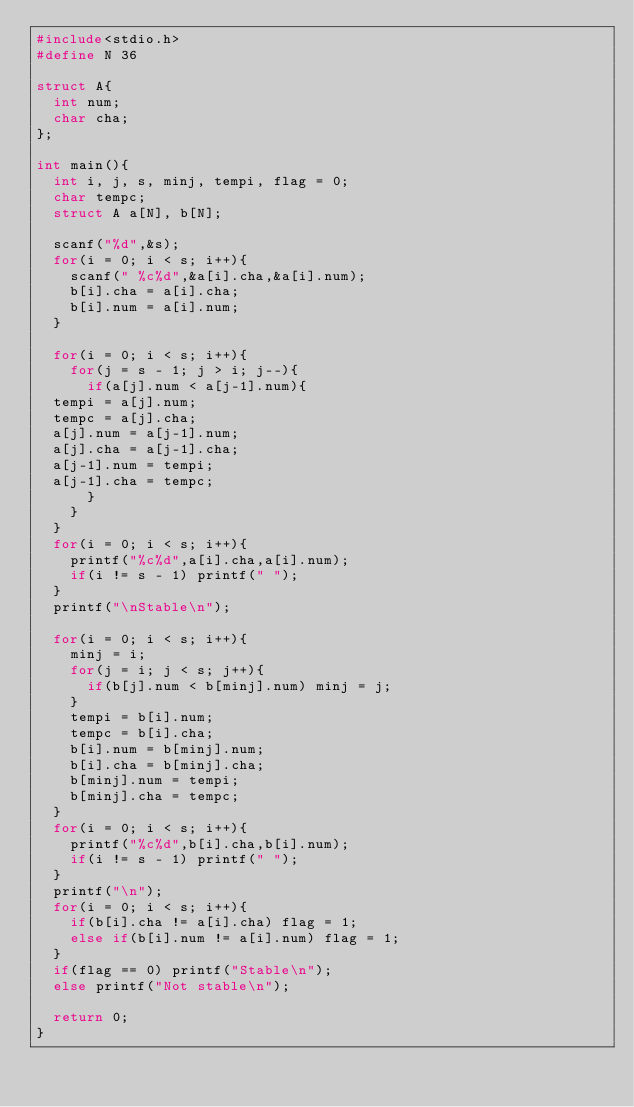<code> <loc_0><loc_0><loc_500><loc_500><_C_>#include<stdio.h>
#define N 36

struct A{
  int num;
  char cha;
};

int main(){
  int i, j, s, minj, tempi, flag = 0;
  char tempc;
  struct A a[N], b[N];

  scanf("%d",&s);
  for(i = 0; i < s; i++){
    scanf(" %c%d",&a[i].cha,&a[i].num);
    b[i].cha = a[i].cha;
    b[i].num = a[i].num;
  }

  for(i = 0; i < s; i++){
    for(j = s - 1; j > i; j--){
      if(a[j].num < a[j-1].num){
	tempi = a[j].num;
	tempc = a[j].cha;
	a[j].num = a[j-1].num;
	a[j].cha = a[j-1].cha;
	a[j-1].num = tempi;
	a[j-1].cha = tempc;
      }
    }
  }
  for(i = 0; i < s; i++){
    printf("%c%d",a[i].cha,a[i].num);
    if(i != s - 1) printf(" ");
  }
  printf("\nStable\n");
  
  for(i = 0; i < s; i++){
    minj = i;
    for(j = i; j < s; j++){
      if(b[j].num < b[minj].num) minj = j;
    }
    tempi = b[i].num;
    tempc = b[i].cha;
    b[i].num = b[minj].num;
    b[i].cha = b[minj].cha;
    b[minj].num = tempi;
    b[minj].cha = tempc;
  }
  for(i = 0; i < s; i++){
    printf("%c%d",b[i].cha,b[i].num);
    if(i != s - 1) printf(" ");
  }
  printf("\n");
  for(i = 0; i < s; i++){
    if(b[i].cha != a[i].cha) flag = 1;
    else if(b[i].num != a[i].num) flag = 1;
  }
  if(flag == 0) printf("Stable\n");
  else printf("Not stable\n");

  return 0;
}</code> 